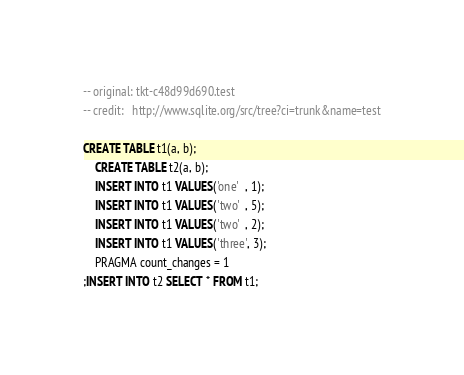Convert code to text. <code><loc_0><loc_0><loc_500><loc_500><_SQL_>-- original: tkt-c48d99d690.test
-- credit:   http://www.sqlite.org/src/tree?ci=trunk&name=test

CREATE TABLE t1(a, b);
    CREATE TABLE t2(a, b);
    INSERT INTO t1 VALUES('one'  , 1);
    INSERT INTO t1 VALUES('two'  , 5);
    INSERT INTO t1 VALUES('two'  , 2);
    INSERT INTO t1 VALUES('three', 3);
    PRAGMA count_changes = 1
;INSERT INTO t2 SELECT * FROM t1;</code> 